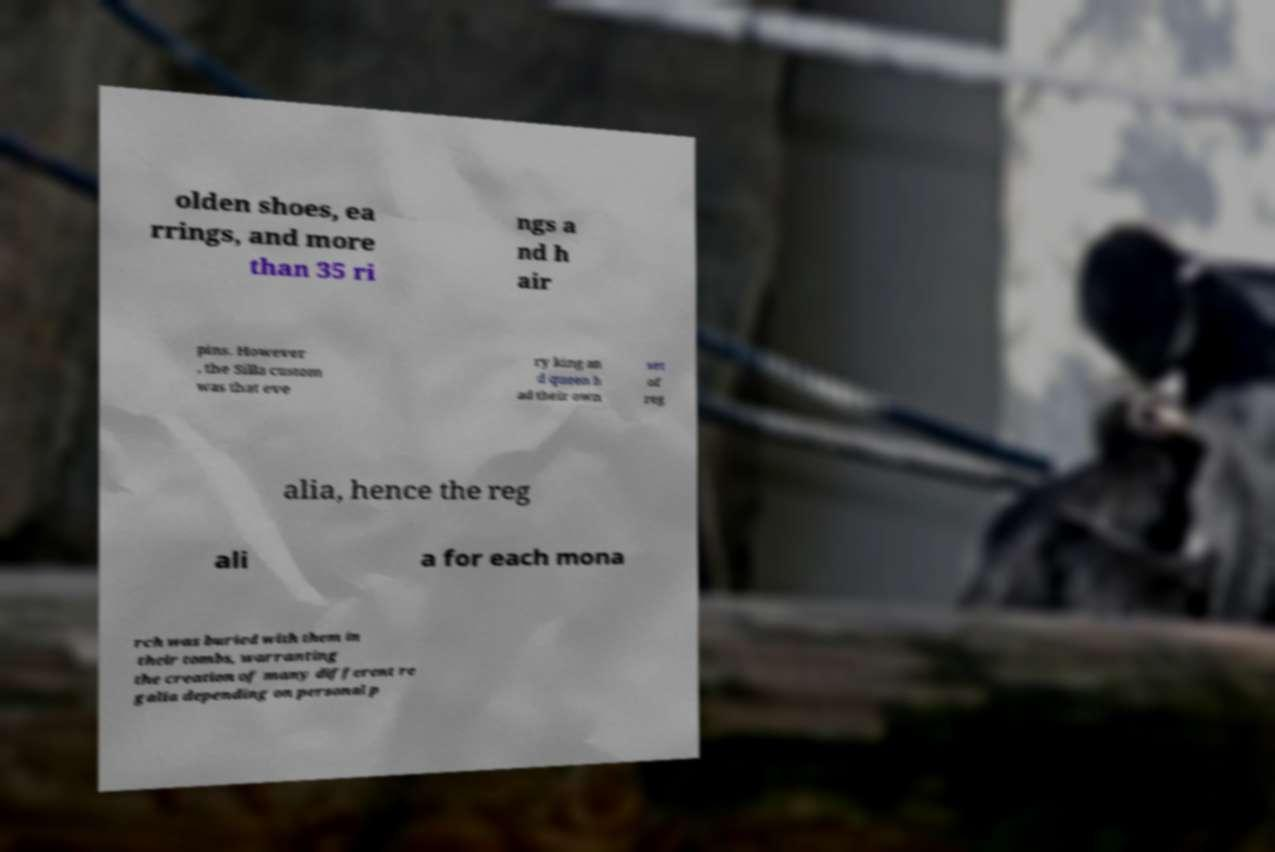I need the written content from this picture converted into text. Can you do that? olden shoes, ea rrings, and more than 35 ri ngs a nd h air pins. However , the Silla custom was that eve ry king an d queen h ad their own set of reg alia, hence the reg ali a for each mona rch was buried with them in their tombs, warranting the creation of many different re galia depending on personal p 